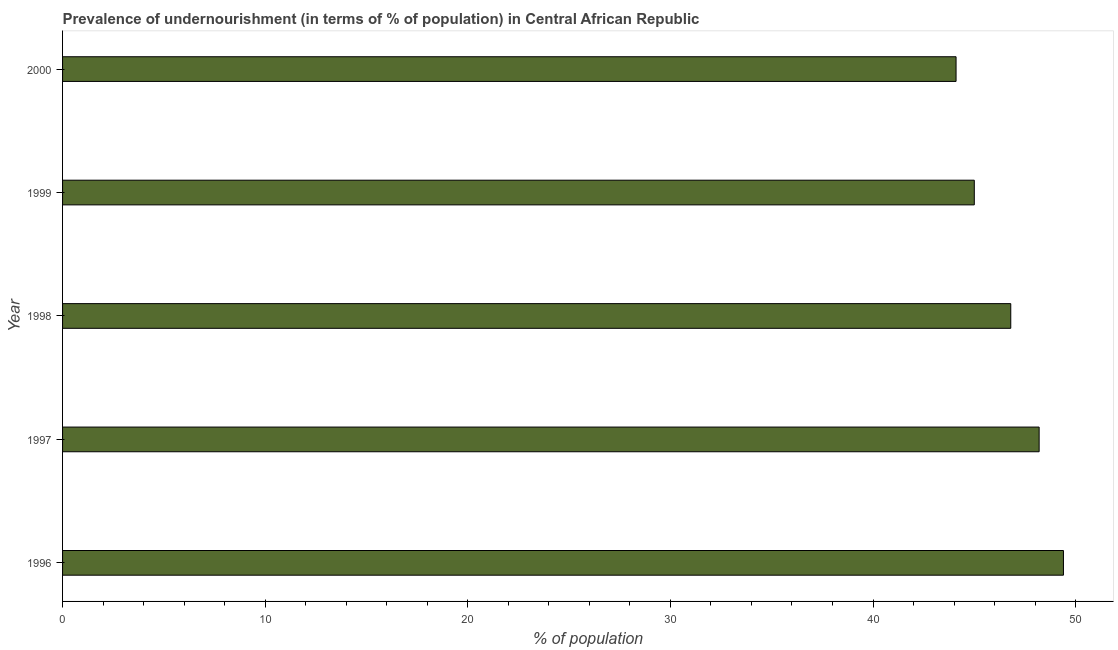Does the graph contain any zero values?
Your response must be concise. No. Does the graph contain grids?
Provide a succinct answer. No. What is the title of the graph?
Make the answer very short. Prevalence of undernourishment (in terms of % of population) in Central African Republic. What is the label or title of the X-axis?
Offer a terse response. % of population. What is the percentage of undernourished population in 2000?
Offer a very short reply. 44.1. Across all years, what is the maximum percentage of undernourished population?
Make the answer very short. 49.4. Across all years, what is the minimum percentage of undernourished population?
Make the answer very short. 44.1. What is the sum of the percentage of undernourished population?
Provide a succinct answer. 233.5. What is the difference between the percentage of undernourished population in 1996 and 1999?
Ensure brevity in your answer.  4.4. What is the average percentage of undernourished population per year?
Offer a very short reply. 46.7. What is the median percentage of undernourished population?
Provide a short and direct response. 46.8. In how many years, is the percentage of undernourished population greater than 46 %?
Offer a very short reply. 3. What is the ratio of the percentage of undernourished population in 1997 to that in 1999?
Provide a short and direct response. 1.07. Is the percentage of undernourished population in 1997 less than that in 1999?
Keep it short and to the point. No. Is the difference between the percentage of undernourished population in 1998 and 1999 greater than the difference between any two years?
Give a very brief answer. No. Is the sum of the percentage of undernourished population in 1996 and 1997 greater than the maximum percentage of undernourished population across all years?
Give a very brief answer. Yes. In how many years, is the percentage of undernourished population greater than the average percentage of undernourished population taken over all years?
Provide a short and direct response. 3. Are all the bars in the graph horizontal?
Give a very brief answer. Yes. How many years are there in the graph?
Give a very brief answer. 5. What is the difference between two consecutive major ticks on the X-axis?
Your response must be concise. 10. Are the values on the major ticks of X-axis written in scientific E-notation?
Ensure brevity in your answer.  No. What is the % of population of 1996?
Make the answer very short. 49.4. What is the % of population in 1997?
Offer a terse response. 48.2. What is the % of population of 1998?
Offer a very short reply. 46.8. What is the % of population of 1999?
Provide a succinct answer. 45. What is the % of population in 2000?
Give a very brief answer. 44.1. What is the difference between the % of population in 1996 and 1997?
Your answer should be compact. 1.2. What is the difference between the % of population in 1996 and 1998?
Ensure brevity in your answer.  2.6. What is the difference between the % of population in 1996 and 1999?
Offer a terse response. 4.4. What is the difference between the % of population in 1997 and 2000?
Offer a terse response. 4.1. What is the difference between the % of population in 1998 and 2000?
Offer a very short reply. 2.7. What is the ratio of the % of population in 1996 to that in 1997?
Keep it short and to the point. 1.02. What is the ratio of the % of population in 1996 to that in 1998?
Give a very brief answer. 1.06. What is the ratio of the % of population in 1996 to that in 1999?
Your response must be concise. 1.1. What is the ratio of the % of population in 1996 to that in 2000?
Provide a short and direct response. 1.12. What is the ratio of the % of population in 1997 to that in 1999?
Ensure brevity in your answer.  1.07. What is the ratio of the % of population in 1997 to that in 2000?
Your response must be concise. 1.09. What is the ratio of the % of population in 1998 to that in 2000?
Ensure brevity in your answer.  1.06. 